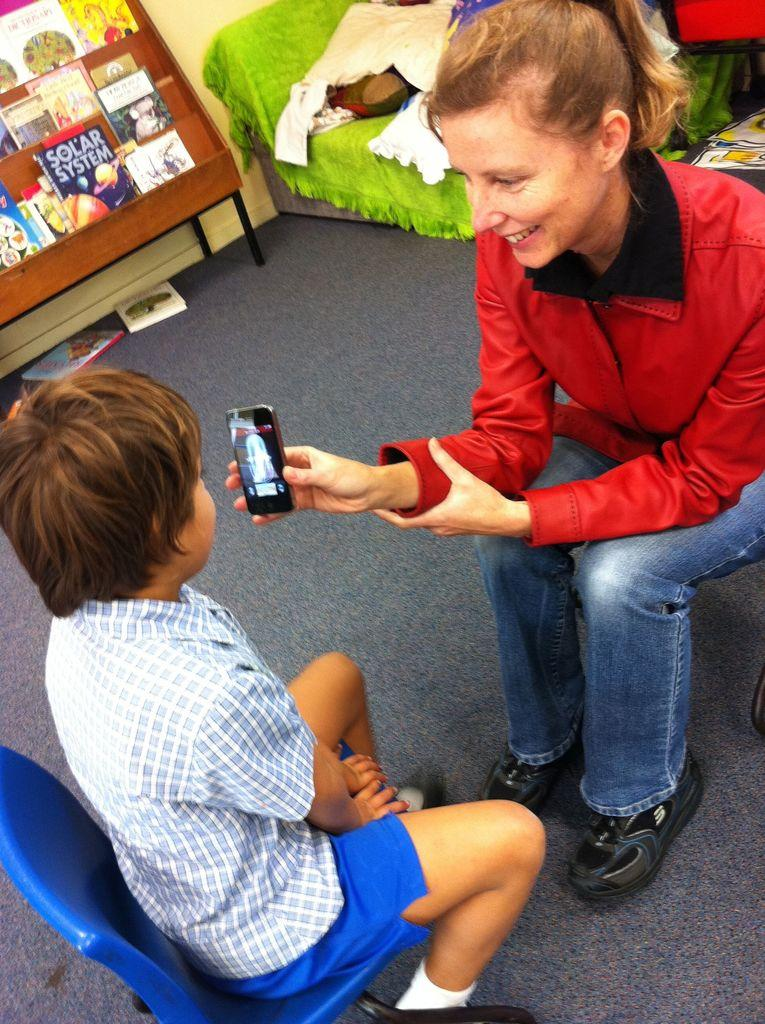Provide a one-sentence caption for the provided image. A woman showing a child a phone screen with a Solar System magazine in the background. 